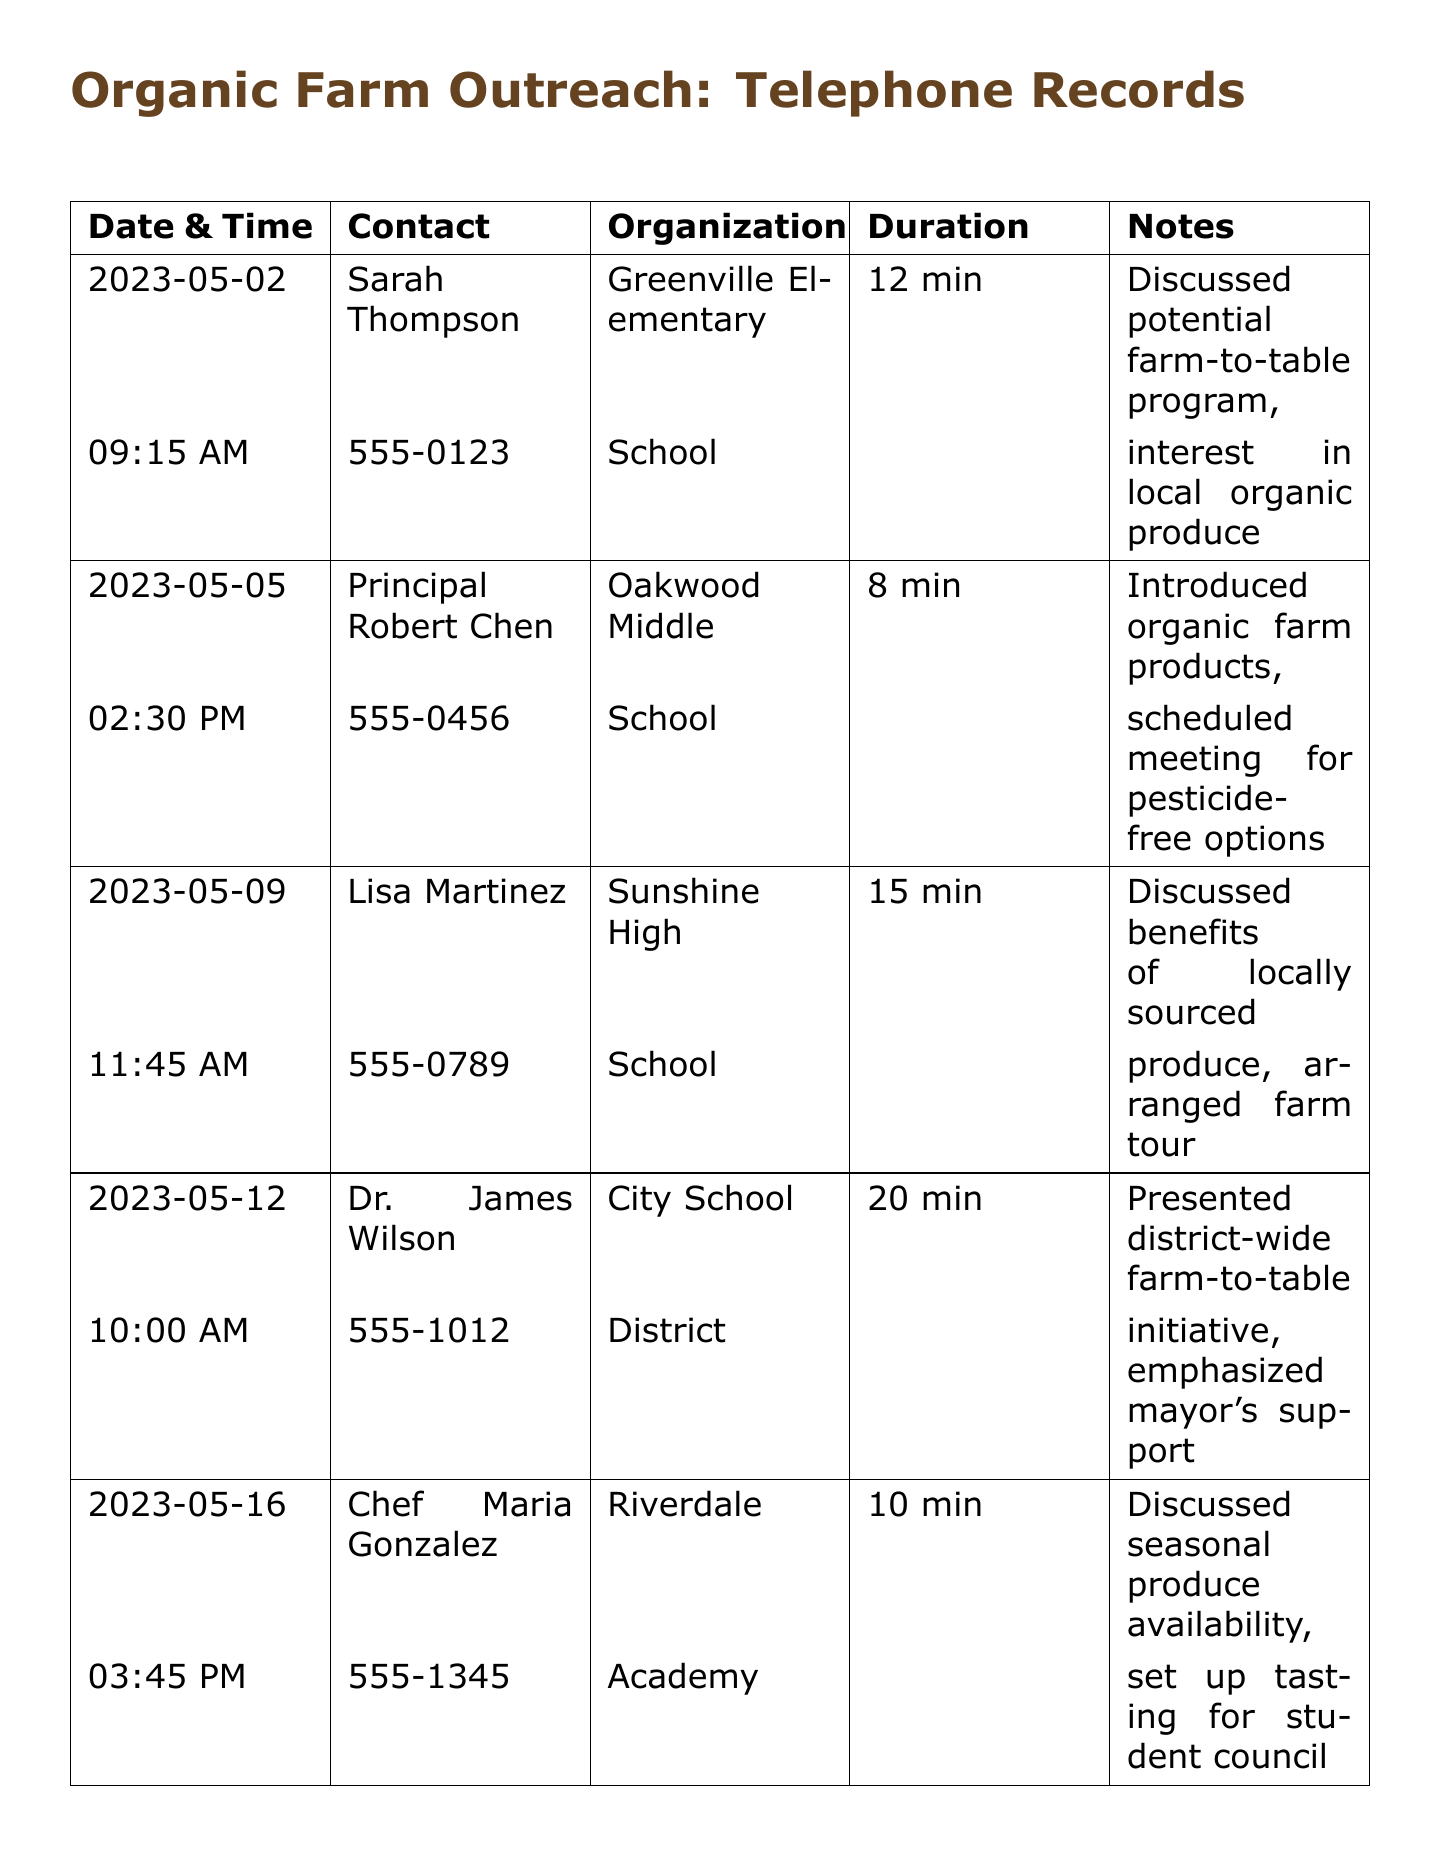what is the date of the first call? The date of the first call is listed in the table under the Date & Time column.
Answer: 2023-05-02 who was contacted at Sunshine High? The contact name for Sunshine High is listed in the table under the Contact column.
Answer: Lisa Martinez how long was the call with Dr. James Wilson? The duration of the call with Dr. James Wilson is provided in the Duration column.
Answer: 20 min what initiative was presented during the call with Dr. James Wilson? The initiative discussed in the call with Dr. James Wilson is detailed in the Notes column.
Answer: district-wide farm-to-table initiative which school had a call about setting up a tasting? The school that discussed setting up a tasting is found in the Notes section.
Answer: Riverdale how many minutes was the call with Chef Maria Gonzalez? The duration of the call with Chef Maria Gonzalez can be found in the Duration column.
Answer: 10 min what is emphasized in the farm-to-table initiative? The emphasis of the farm-to-table initiative is mentioned in the Notes section.
Answer: mayor's support what type of produce was discussed during the call with Sarah Thompson? The type of produce discussed with Sarah Thompson is stated in the Notes section.
Answer: local organic produce 